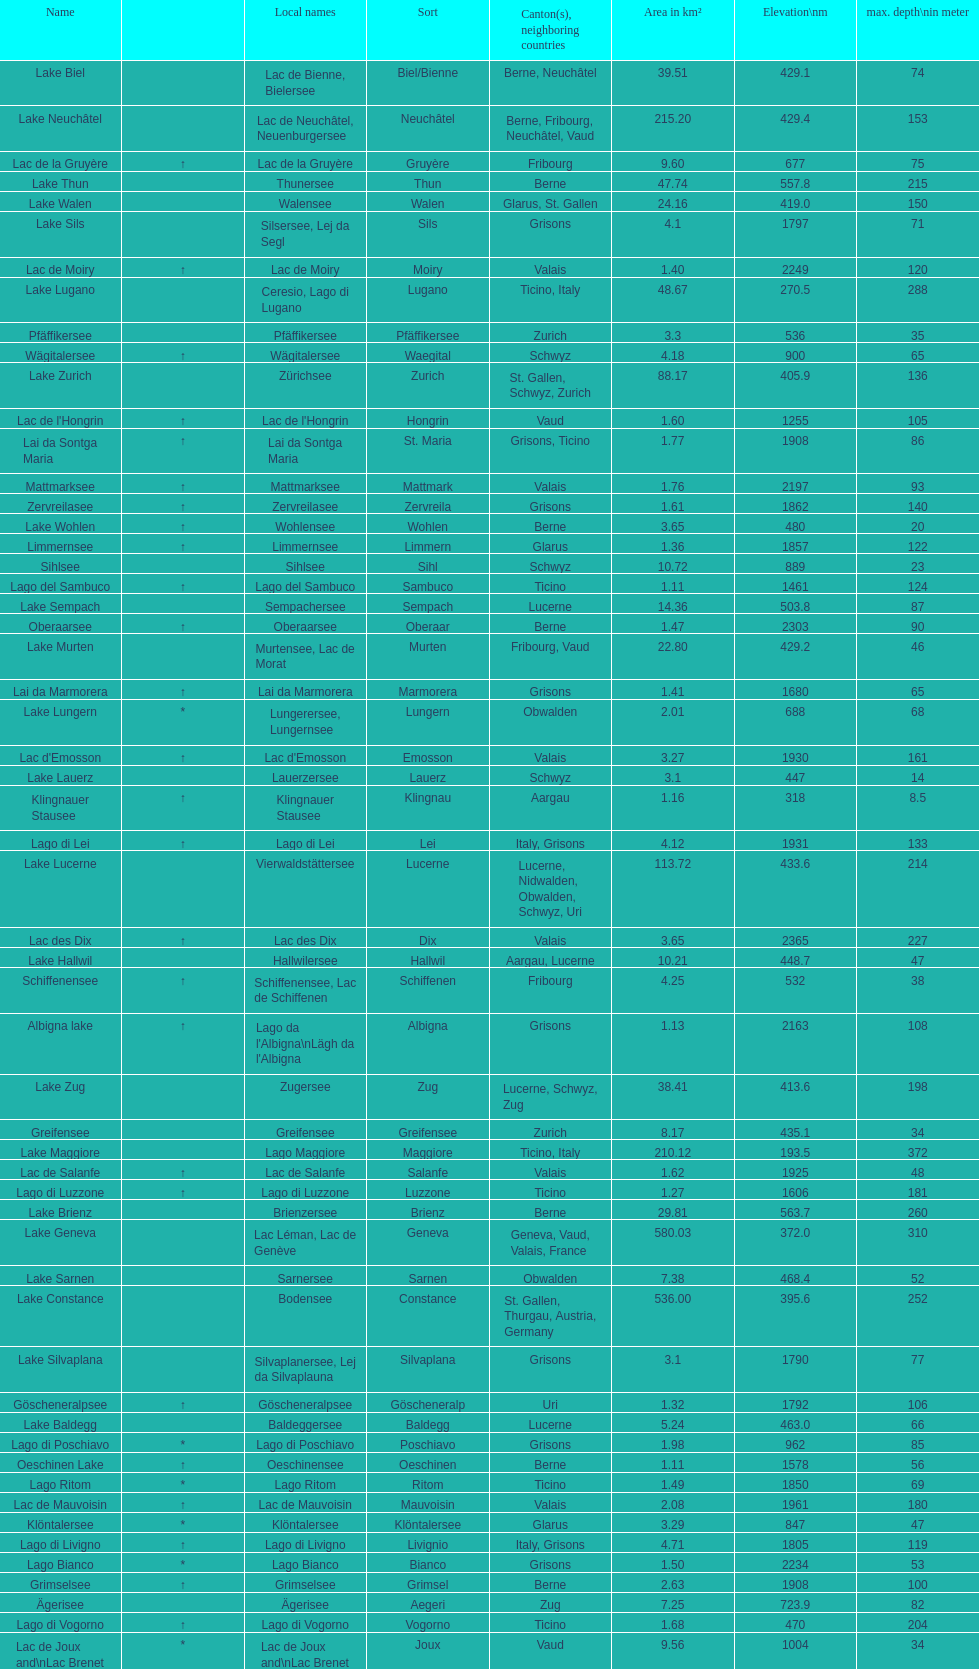Which is the only lake with a max depth of 372m? Lake Maggiore. 